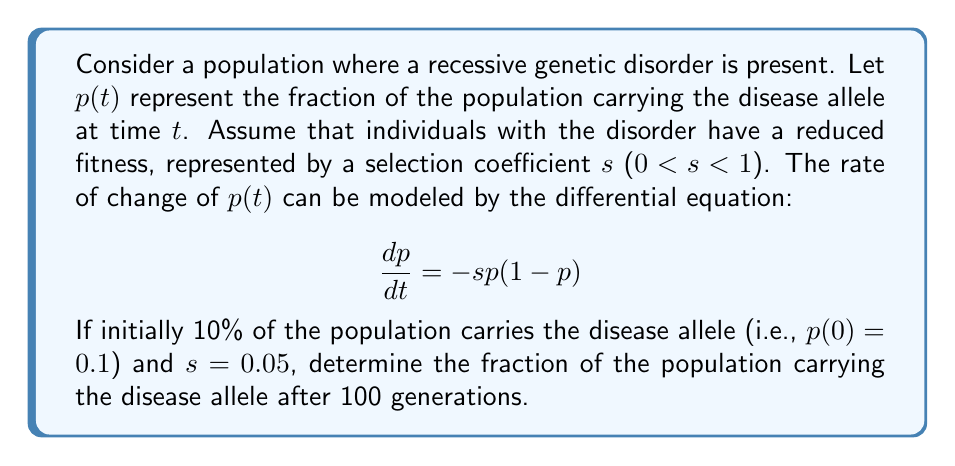Could you help me with this problem? To solve this problem, we need to follow these steps:

1) First, we need to solve the differential equation:

   $$\frac{dp}{dt} = -sp(1-p)$$

2) This is a separable differential equation. We can rewrite it as:

   $$\frac{dp}{p(1-p)} = -s dt$$

3) Integrating both sides:

   $$\int \frac{dp}{p(1-p)} = -s \int dt$$

4) The left side can be integrated using partial fractions:

   $$\ln(\frac{p}{1-p}) = -st + C$$

5) Solving for $p$:

   $$p = \frac{1}{1 + Ae^{st}}$$

   where $A$ is a constant determined by the initial condition.

6) Using the initial condition $p(0) = 0.1$:

   $$0.1 = \frac{1}{1 + A}$$

   Solving for $A$:

   $$A = 9$$

7) Therefore, our solution is:

   $$p(t) = \frac{1}{1 + 9e^{0.05t}}$$

8) To find $p(100)$, we substitute $t = 100$:

   $$p(100) = \frac{1}{1 + 9e^{5}}$$

9) Calculating this value:

   $$p(100) \approx 0.0067$$
Answer: After 100 generations, approximately 0.67% of the population will carry the disease allele. 